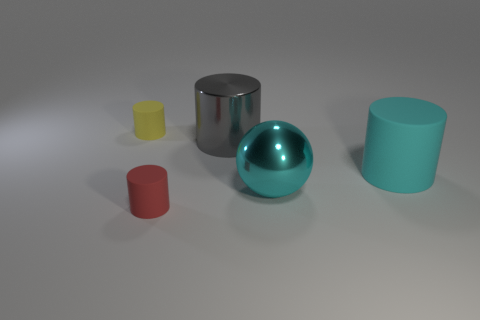Add 4 yellow rubber cylinders. How many objects exist? 9 Subtract all cylinders. How many objects are left? 1 Add 3 big shiny cylinders. How many big shiny cylinders exist? 4 Subtract 0 blue spheres. How many objects are left? 5 Subtract all large cyan matte things. Subtract all cyan rubber cylinders. How many objects are left? 3 Add 2 tiny yellow cylinders. How many tiny yellow cylinders are left? 3 